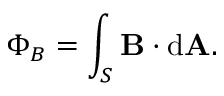Convert formula to latex. <formula><loc_0><loc_0><loc_500><loc_500>\Phi _ { B } = \int _ { S } B \cdot d A . \,</formula> 